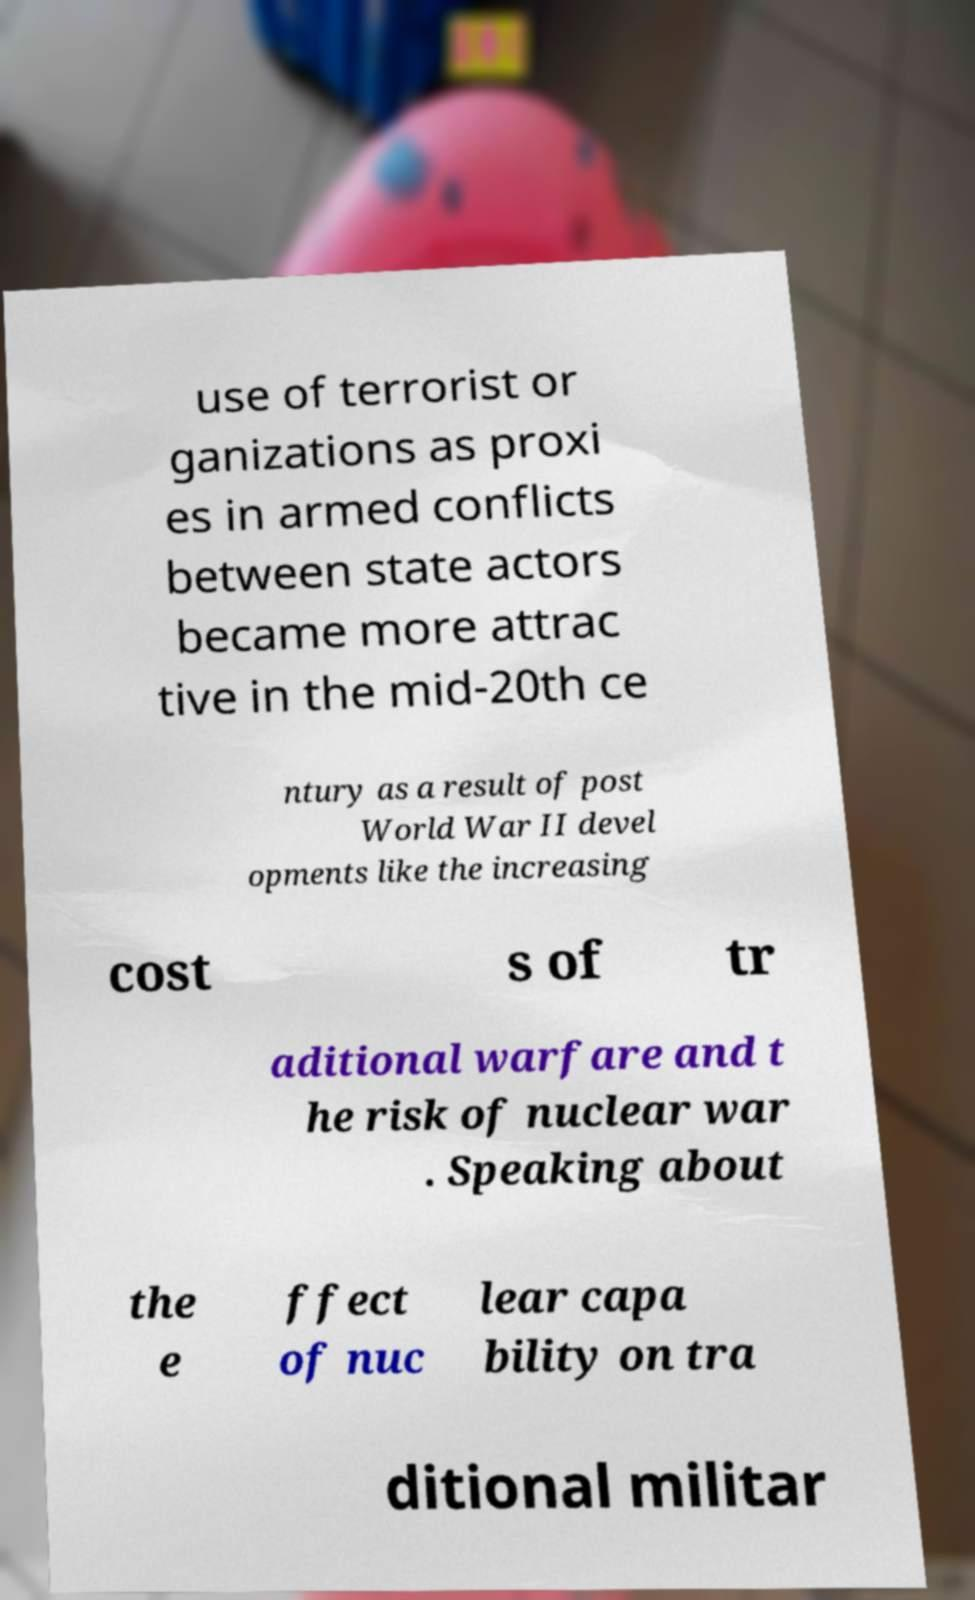Please read and relay the text visible in this image. What does it say? use of terrorist or ganizations as proxi es in armed conflicts between state actors became more attrac tive in the mid-20th ce ntury as a result of post World War II devel opments like the increasing cost s of tr aditional warfare and t he risk of nuclear war . Speaking about the e ffect of nuc lear capa bility on tra ditional militar 